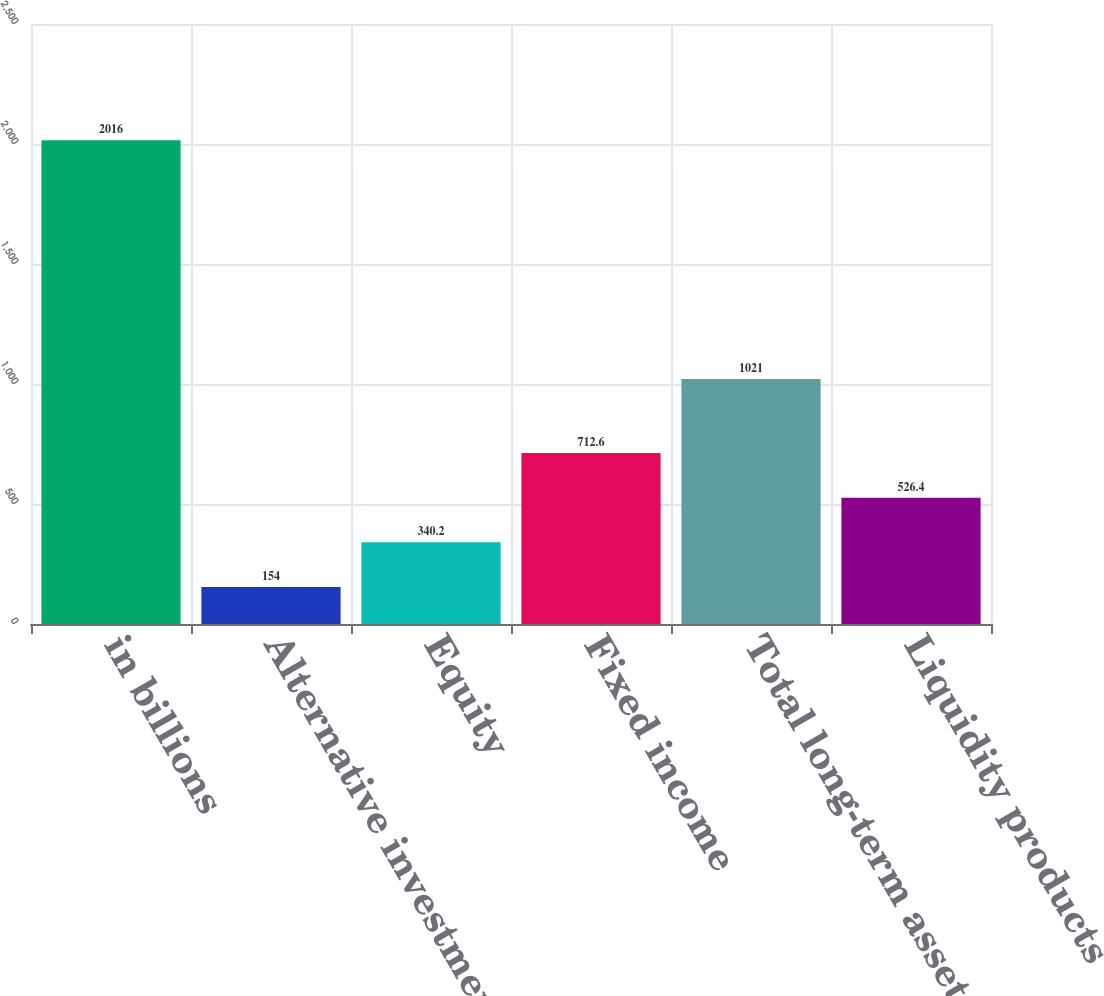<chart> <loc_0><loc_0><loc_500><loc_500><bar_chart><fcel>in billions<fcel>Alternative investments<fcel>Equity<fcel>Fixed income<fcel>Total long-term assets under<fcel>Liquidity products<nl><fcel>2016<fcel>154<fcel>340.2<fcel>712.6<fcel>1021<fcel>526.4<nl></chart> 